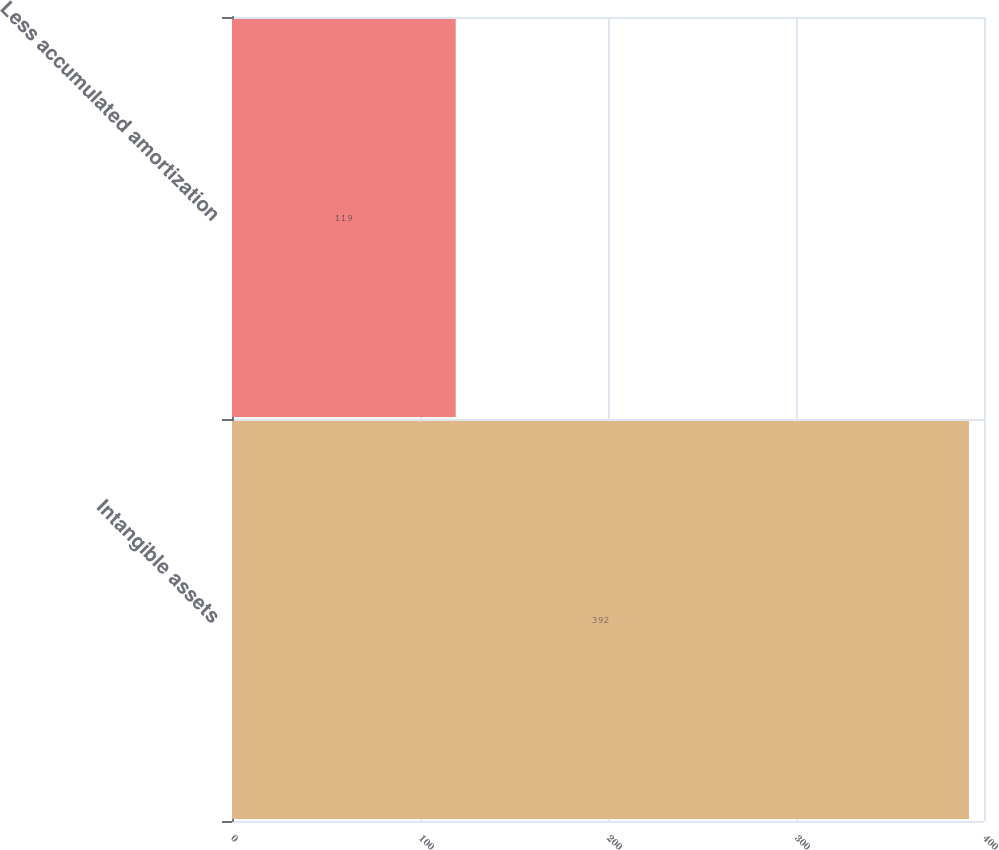<chart> <loc_0><loc_0><loc_500><loc_500><bar_chart><fcel>Intangible assets<fcel>Less accumulated amortization<nl><fcel>392<fcel>119<nl></chart> 